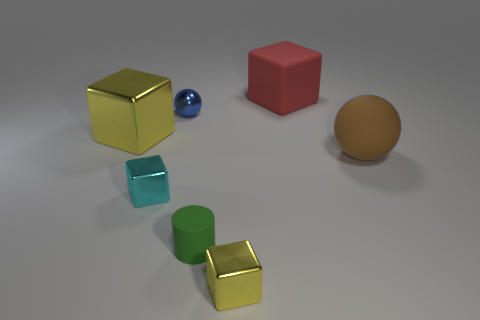Add 2 blue shiny things. How many objects exist? 9 Subtract all cylinders. How many objects are left? 6 Add 1 large brown matte blocks. How many large brown matte blocks exist? 1 Subtract 1 blue spheres. How many objects are left? 6 Subtract all large yellow shiny spheres. Subtract all big matte spheres. How many objects are left? 6 Add 6 tiny metal cubes. How many tiny metal cubes are left? 8 